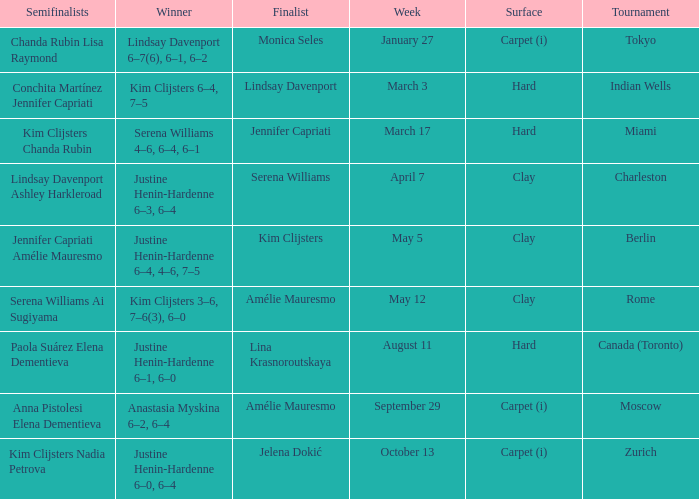Who was the finalist in Miami? Jennifer Capriati. 